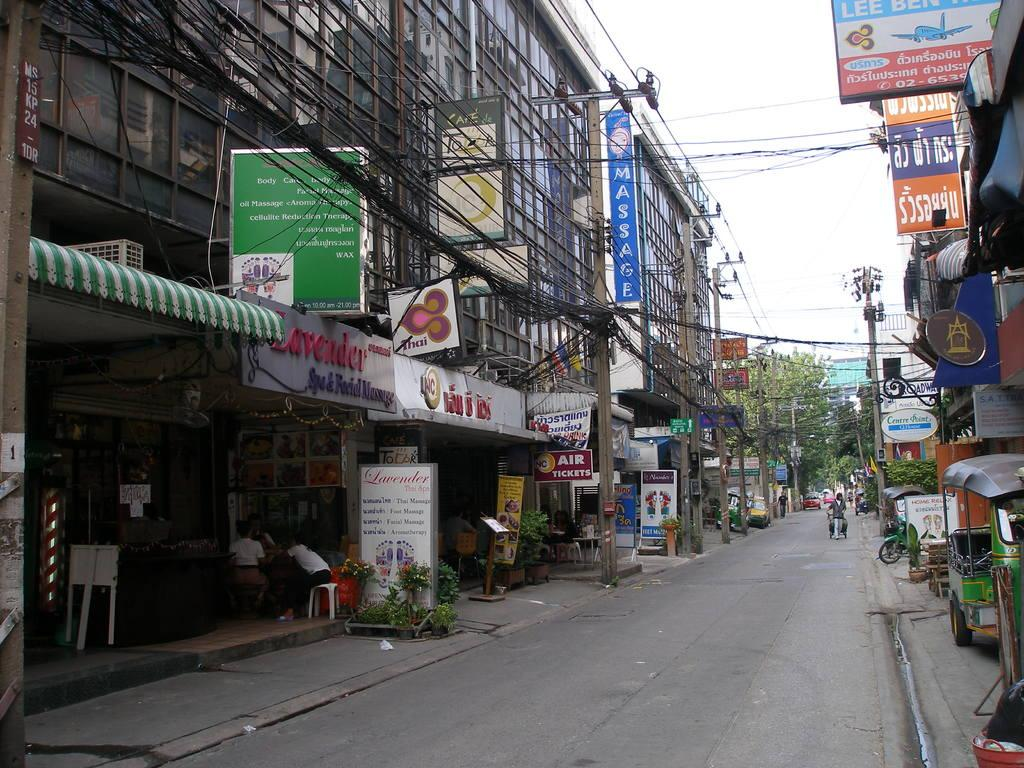What is the main feature of the image? There is a road in the image. What else can be seen along the road? There are shops, boards, trees, and places visible in the image. Are there any other structures or elements in the image? Yes, there are cables in the image. What is visible at the top of the image? The sky is visible at the top of the image. Where are the cherries located in the image? There are no cherries present in the image. What type of badge can be seen on the trees in the image? There are no badges present on the trees in the image. 